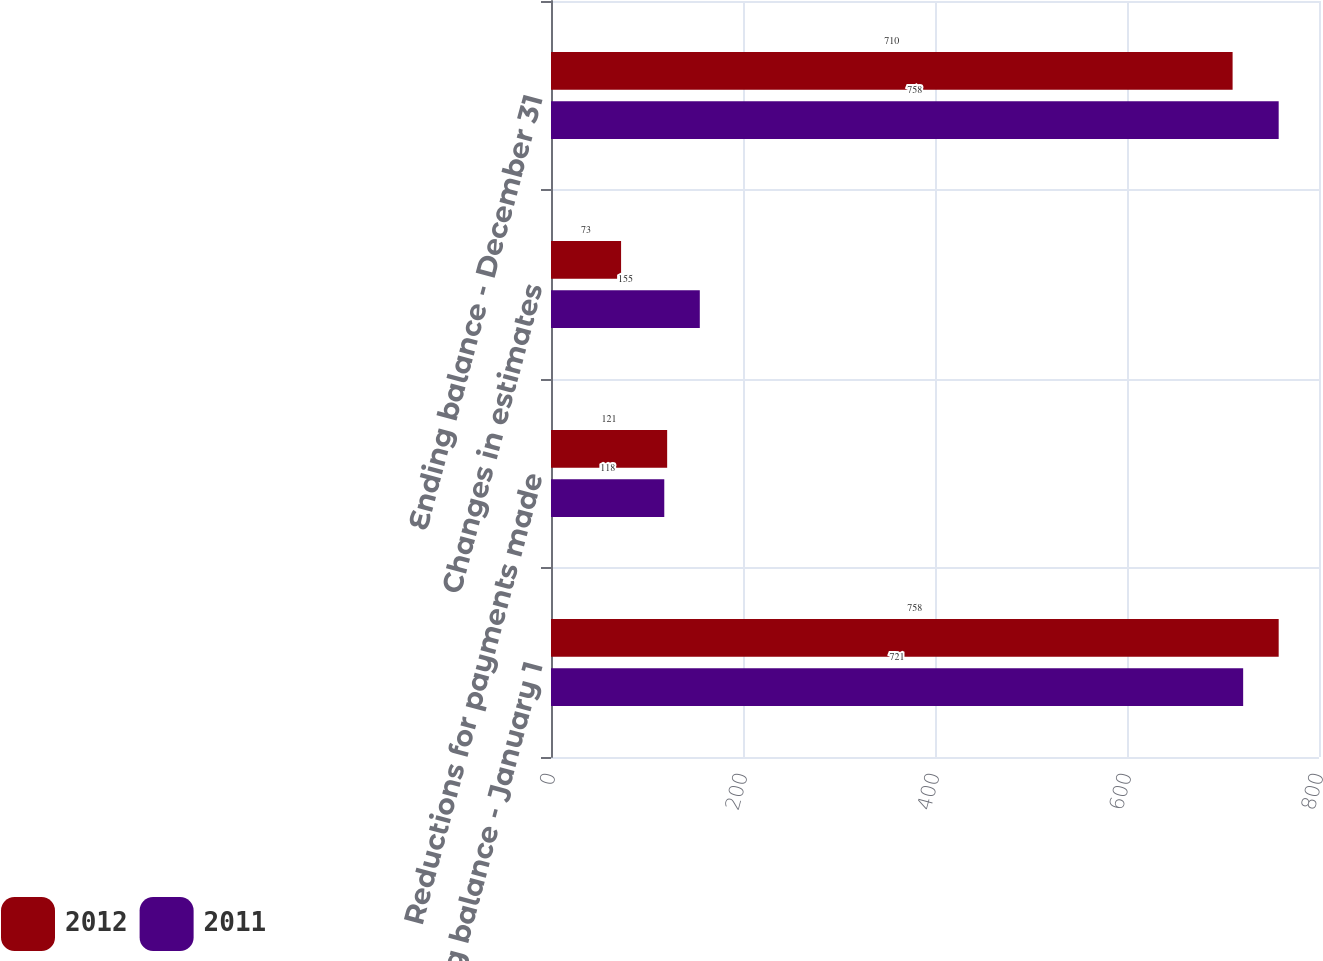Convert chart to OTSL. <chart><loc_0><loc_0><loc_500><loc_500><stacked_bar_chart><ecel><fcel>Beginning balance - January 1<fcel>Reductions for payments made<fcel>Changes in estimates<fcel>Ending balance - December 31<nl><fcel>2012<fcel>758<fcel>121<fcel>73<fcel>710<nl><fcel>2011<fcel>721<fcel>118<fcel>155<fcel>758<nl></chart> 